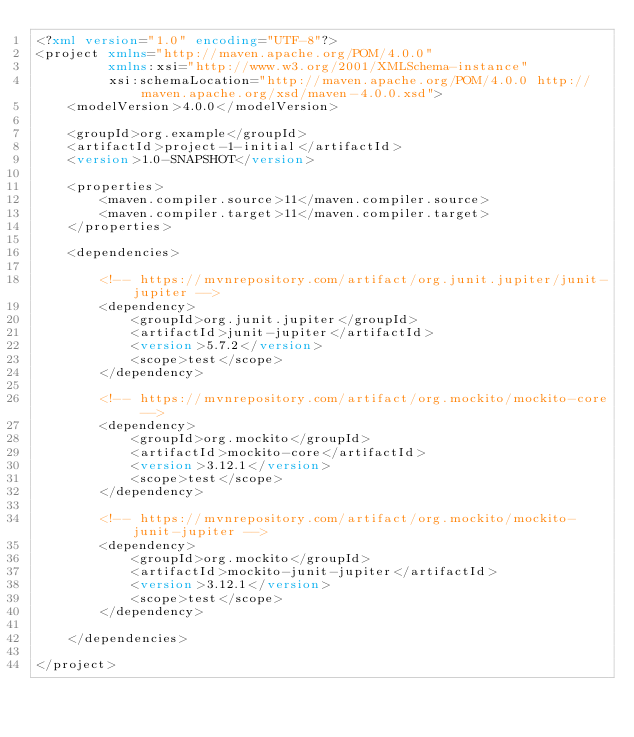<code> <loc_0><loc_0><loc_500><loc_500><_XML_><?xml version="1.0" encoding="UTF-8"?>
<project xmlns="http://maven.apache.org/POM/4.0.0"
         xmlns:xsi="http://www.w3.org/2001/XMLSchema-instance"
         xsi:schemaLocation="http://maven.apache.org/POM/4.0.0 http://maven.apache.org/xsd/maven-4.0.0.xsd">
    <modelVersion>4.0.0</modelVersion>

    <groupId>org.example</groupId>
    <artifactId>project-1-initial</artifactId>
    <version>1.0-SNAPSHOT</version>

    <properties>
        <maven.compiler.source>11</maven.compiler.source>
        <maven.compiler.target>11</maven.compiler.target>
    </properties>

    <dependencies>

        <!-- https://mvnrepository.com/artifact/org.junit.jupiter/junit-jupiter -->
        <dependency>
            <groupId>org.junit.jupiter</groupId>
            <artifactId>junit-jupiter</artifactId>
            <version>5.7.2</version>
            <scope>test</scope>
        </dependency>

        <!-- https://mvnrepository.com/artifact/org.mockito/mockito-core -->
        <dependency>
            <groupId>org.mockito</groupId>
            <artifactId>mockito-core</artifactId>
            <version>3.12.1</version>
            <scope>test</scope>
        </dependency>

        <!-- https://mvnrepository.com/artifact/org.mockito/mockito-junit-jupiter -->
        <dependency>
            <groupId>org.mockito</groupId>
            <artifactId>mockito-junit-jupiter</artifactId>
            <version>3.12.1</version>
            <scope>test</scope>
        </dependency>

    </dependencies>

</project>
</code> 